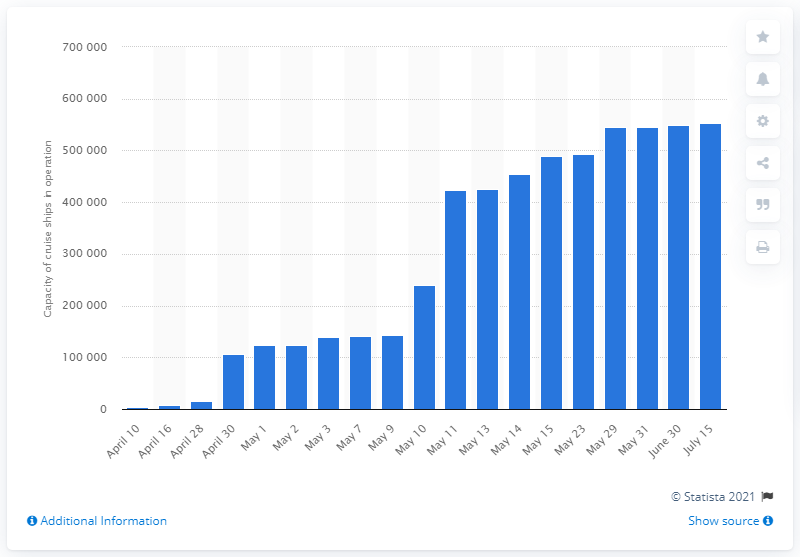Give some essential details in this illustration. The expected resumption of cruise ship operations was on May 11. 